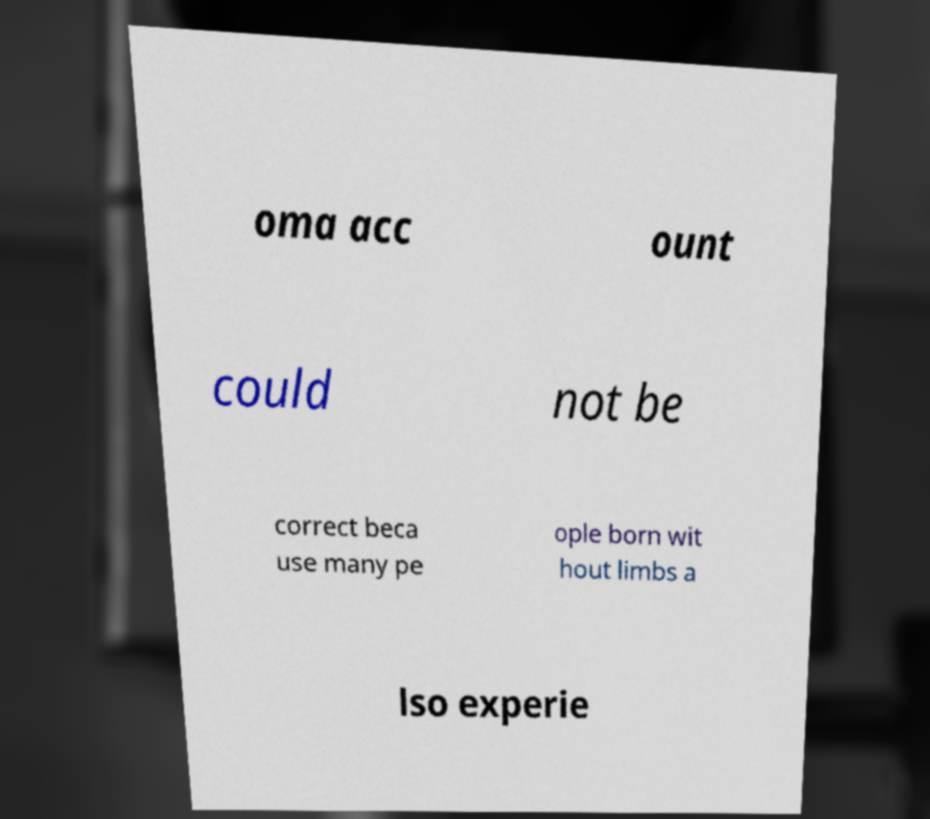Please read and relay the text visible in this image. What does it say? oma acc ount could not be correct beca use many pe ople born wit hout limbs a lso experie 